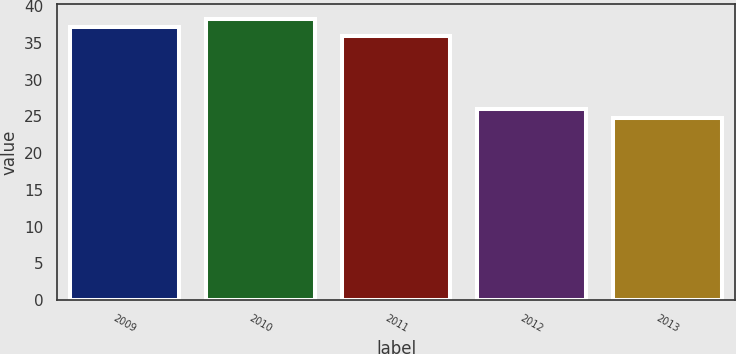Convert chart. <chart><loc_0><loc_0><loc_500><loc_500><bar_chart><fcel>2009<fcel>2010<fcel>2011<fcel>2012<fcel>2013<nl><fcel>37.12<fcel>38.34<fcel>35.9<fcel>26.02<fcel>24.8<nl></chart> 